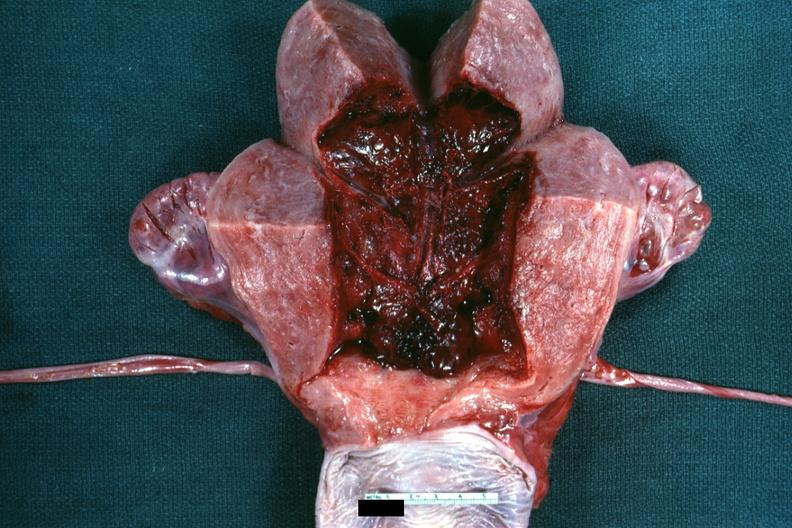what is present?
Answer the question using a single word or phrase. Uterus 